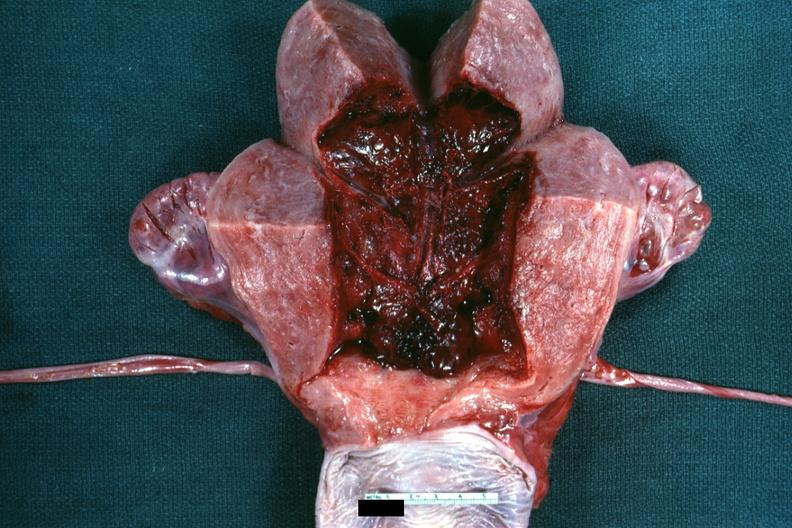what is present?
Answer the question using a single word or phrase. Uterus 